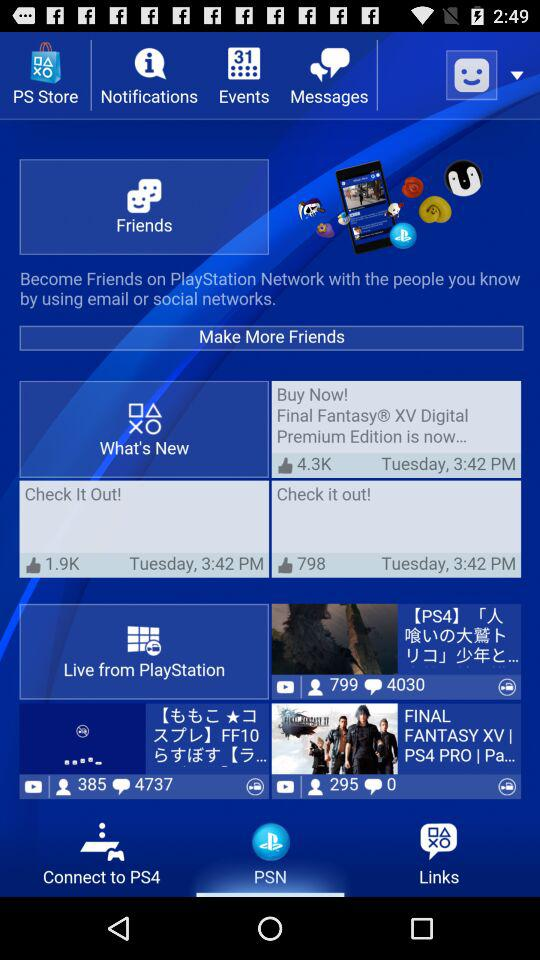What is the checkout time where the number of likes is 1.9K? The checkout time is 3:42 PM. 